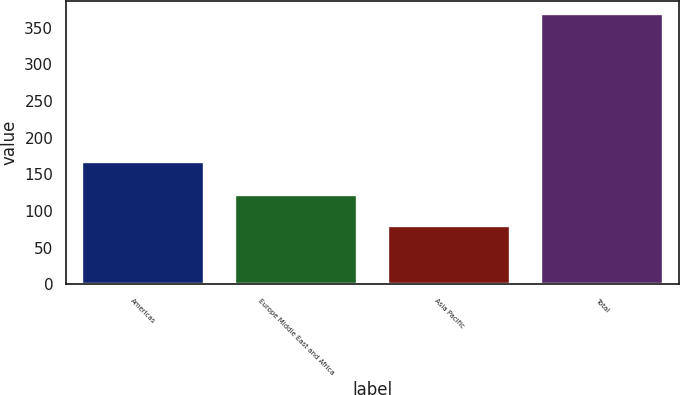<chart> <loc_0><loc_0><loc_500><loc_500><bar_chart><fcel>Americas<fcel>Europe Middle East and Africa<fcel>Asia Pacific<fcel>Total<nl><fcel>167<fcel>122<fcel>79<fcel>368<nl></chart> 